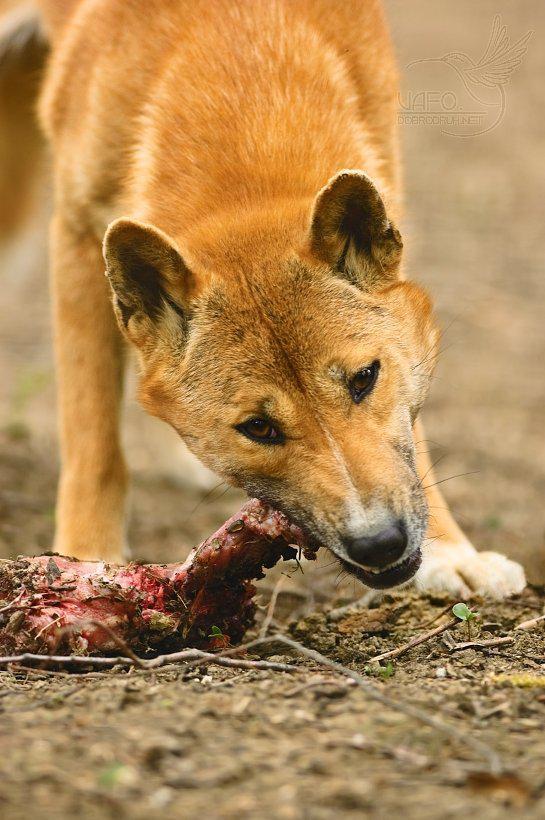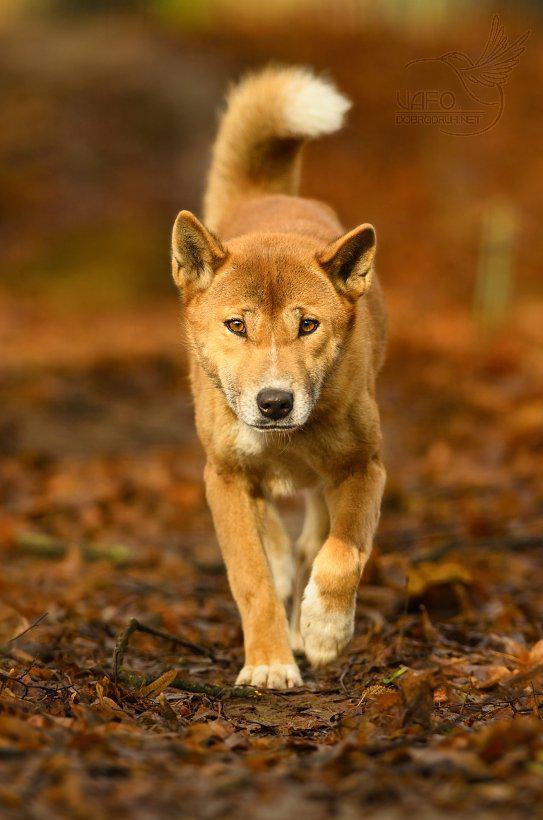The first image is the image on the left, the second image is the image on the right. Analyze the images presented: Is the assertion "The animal in the image on the right is looking toward the camera" valid? Answer yes or no. Yes. The first image is the image on the left, the second image is the image on the right. For the images shown, is this caption "Right image shows a canine looking directly into the camera." true? Answer yes or no. Yes. 